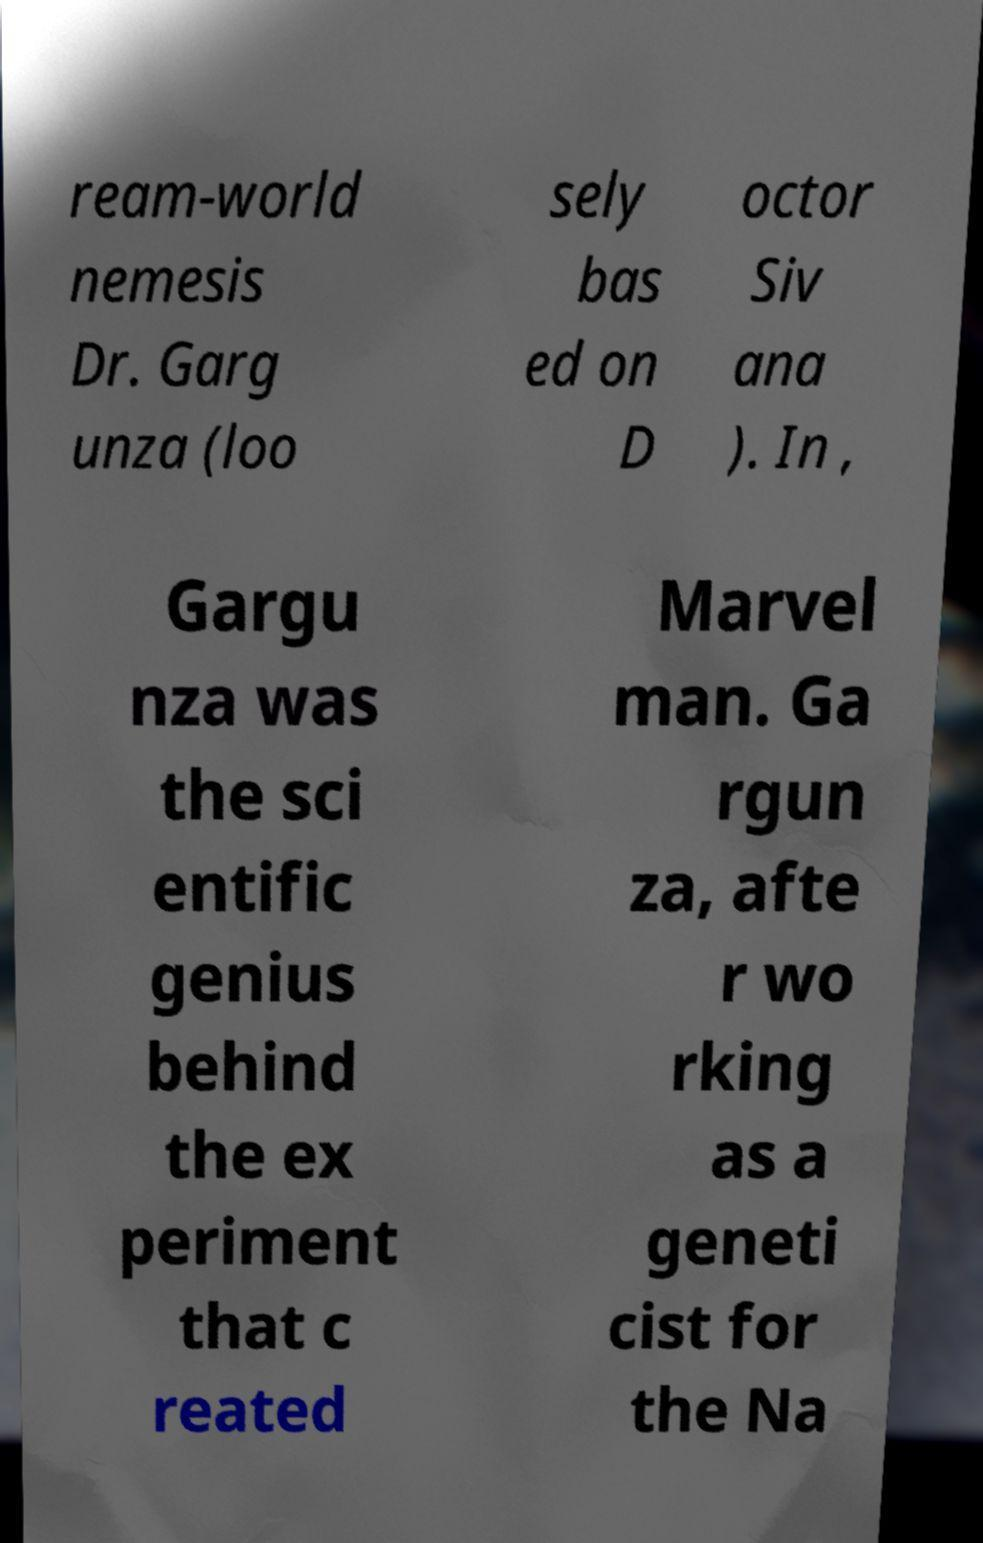What messages or text are displayed in this image? I need them in a readable, typed format. ream-world nemesis Dr. Garg unza (loo sely bas ed on D octor Siv ana ). In , Gargu nza was the sci entific genius behind the ex periment that c reated Marvel man. Ga rgun za, afte r wo rking as a geneti cist for the Na 